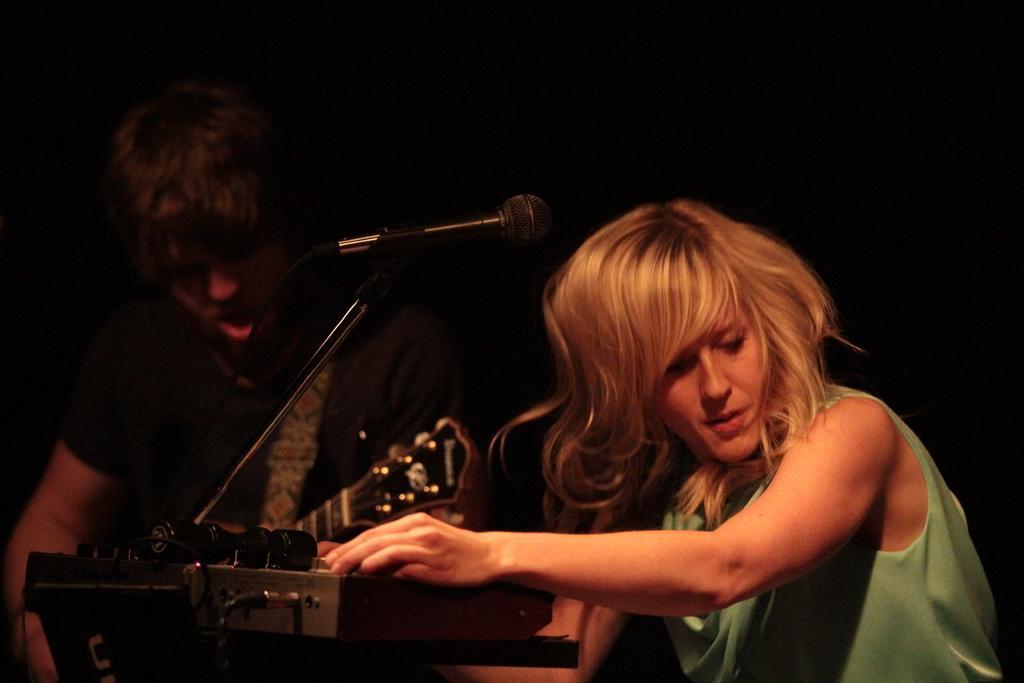How would you summarize this image in a sentence or two? In this image, we can see two persons on the dark background wearing clothes. There is a mic in the middle of the image. 